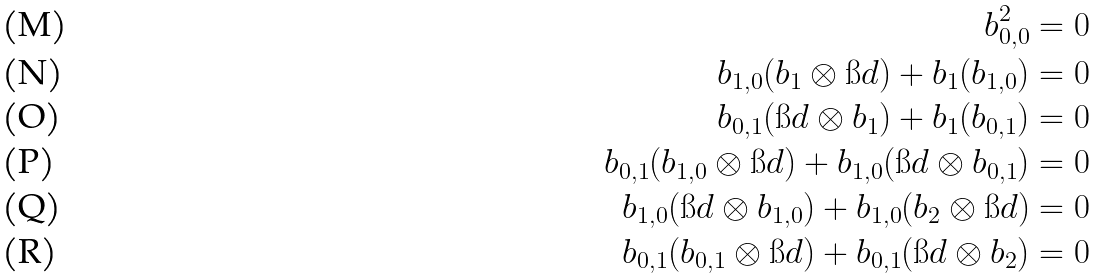<formula> <loc_0><loc_0><loc_500><loc_500>b _ { 0 , 0 } ^ { 2 } & = 0 \\ b _ { 1 , 0 } ( b _ { 1 } \otimes \i d ) + b _ { 1 } ( b _ { 1 , 0 } ) & = 0 \\ b _ { 0 , 1 } ( \i d \otimes b _ { 1 } ) + b _ { 1 } ( b _ { 0 , 1 } ) & = 0 \\ b _ { 0 , 1 } ( b _ { 1 , 0 } \otimes \i d ) + b _ { 1 , 0 } ( \i d \otimes b _ { 0 , 1 } ) & = 0 \\ b _ { 1 , 0 } ( \i d \otimes b _ { 1 , 0 } ) + b _ { 1 , 0 } ( b _ { 2 } \otimes \i d ) & = 0 \\ b _ { 0 , 1 } ( b _ { 0 , 1 } \otimes \i d ) + b _ { 0 , 1 } ( \i d \otimes b _ { 2 } ) & = 0</formula> 